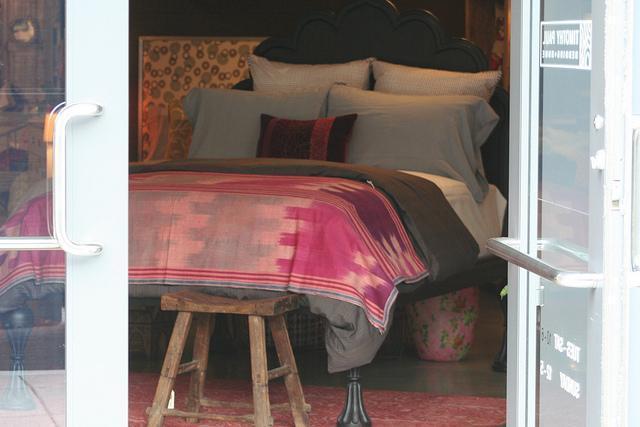How many beds are there?
Give a very brief answer. 1. How many people are lying down underneath the truck?
Give a very brief answer. 0. 